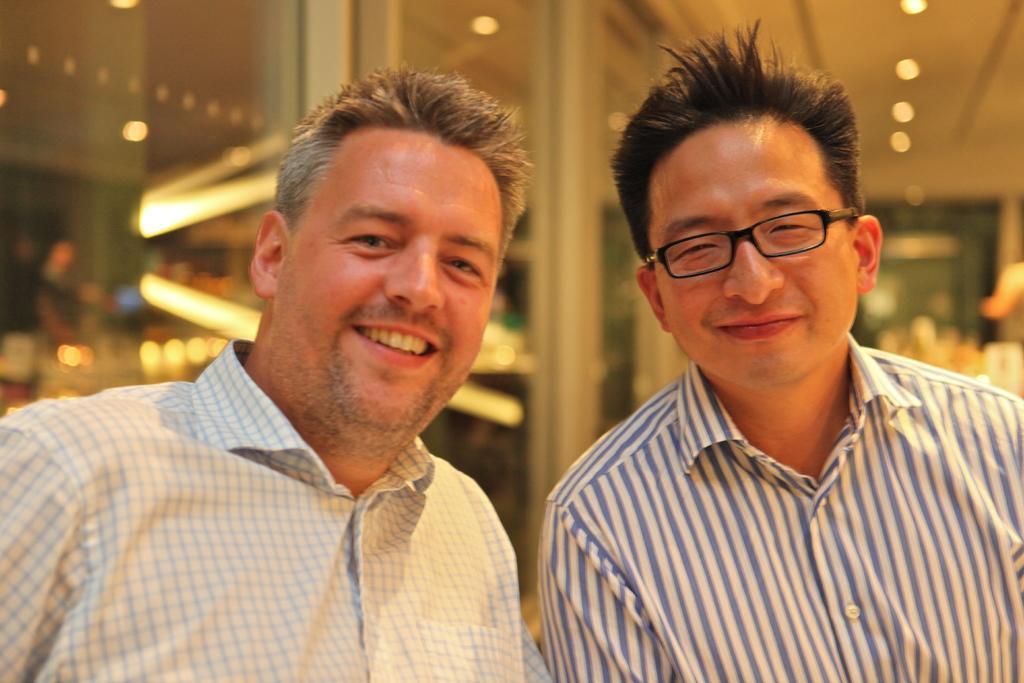Could you give a brief overview of what you see in this image? In this picture there are two men who are wearing white shirt and smiling. In the back I can see the glass partition, doors and blur image. At the top I can see some lights on the roof. 